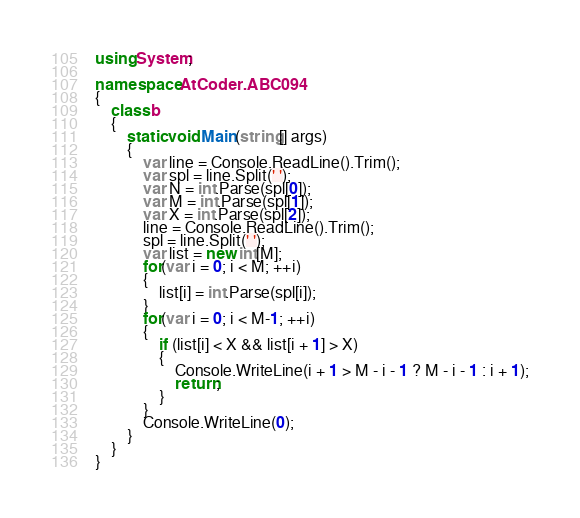<code> <loc_0><loc_0><loc_500><loc_500><_C#_>using System;

namespace AtCoder.ABC094
{
    class b
    {
        static void Main(string[] args)
        {
            var line = Console.ReadLine().Trim();
            var spl = line.Split(' ');
            var N = int.Parse(spl[0]);
            var M = int.Parse(spl[1]);
            var X = int.Parse(spl[2]);
            line = Console.ReadLine().Trim();
            spl = line.Split(' ');
            var list = new int[M];
            for(var i = 0; i < M; ++i)
            {
                list[i] = int.Parse(spl[i]);
            }
            for(var i = 0; i < M-1; ++i)
            {
                if (list[i] < X && list[i + 1] > X)
                {
                    Console.WriteLine(i + 1 > M - i - 1 ? M - i - 1 : i + 1);
                    return;
                }
            }
            Console.WriteLine(0);
        }
    }
}
</code> 